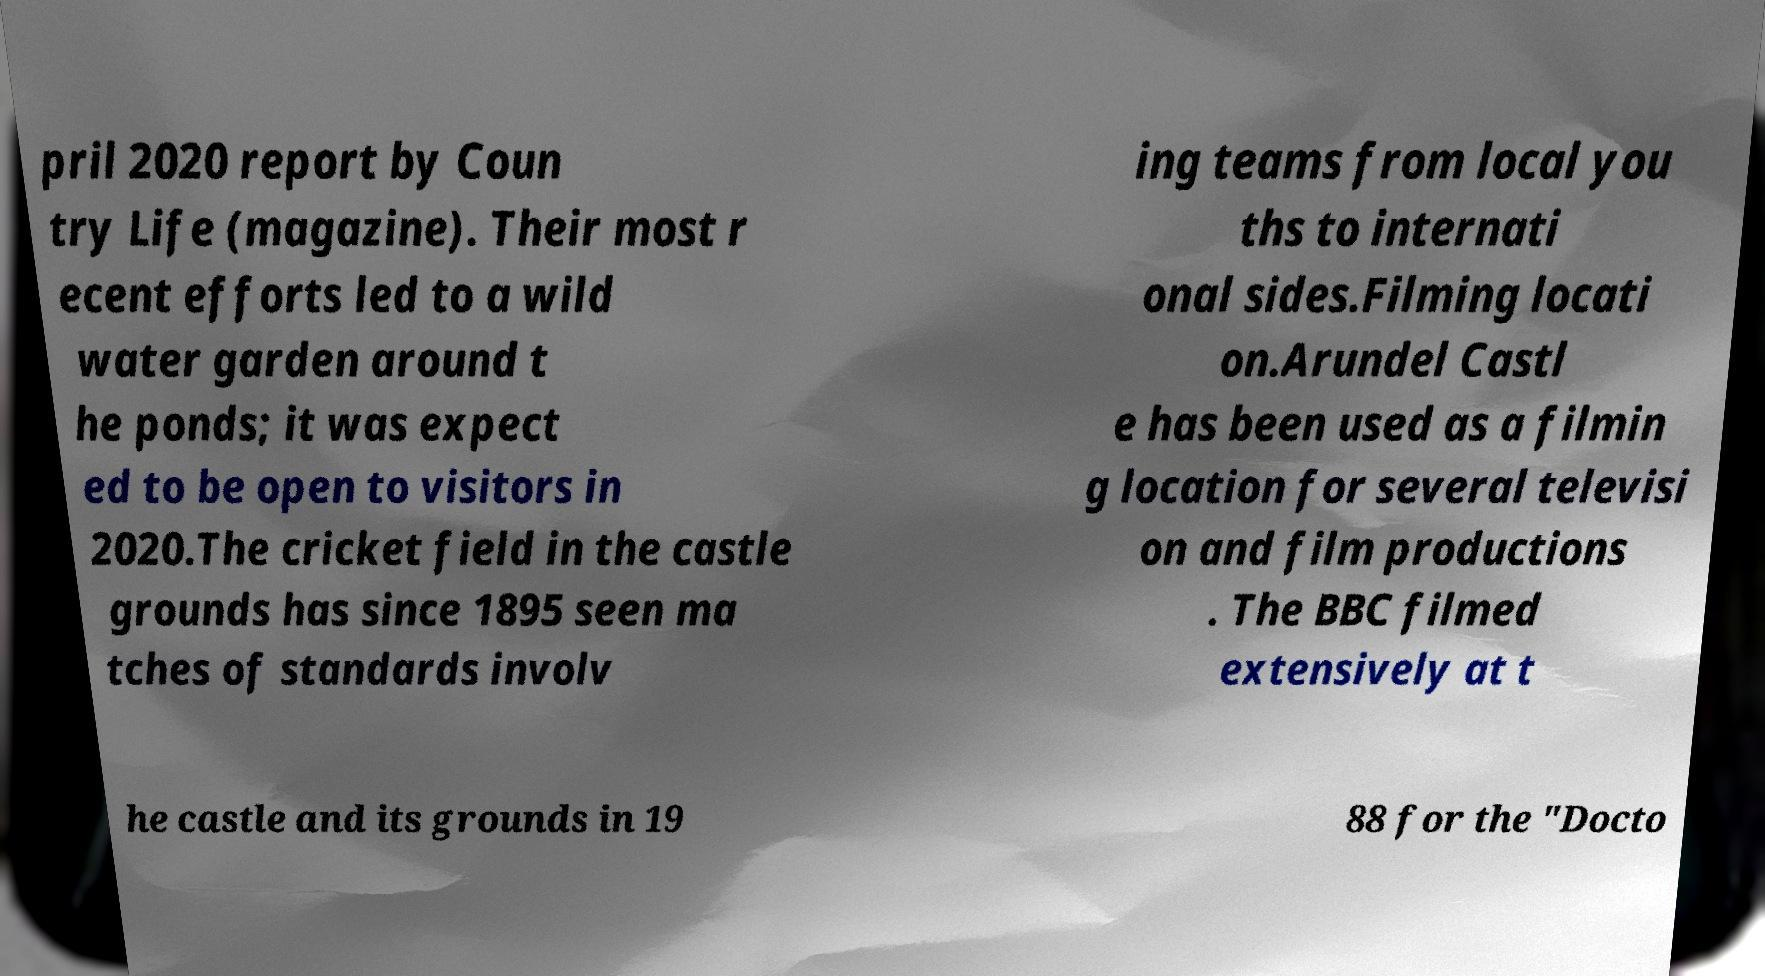Could you extract and type out the text from this image? pril 2020 report by Coun try Life (magazine). Their most r ecent efforts led to a wild water garden around t he ponds; it was expect ed to be open to visitors in 2020.The cricket field in the castle grounds has since 1895 seen ma tches of standards involv ing teams from local you ths to internati onal sides.Filming locati on.Arundel Castl e has been used as a filmin g location for several televisi on and film productions . The BBC filmed extensively at t he castle and its grounds in 19 88 for the "Docto 